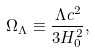Convert formula to latex. <formula><loc_0><loc_0><loc_500><loc_500>\Omega _ { \Lambda } \equiv \frac { \Lambda c ^ { 2 } } { 3 H _ { 0 } ^ { 2 } } ,</formula> 